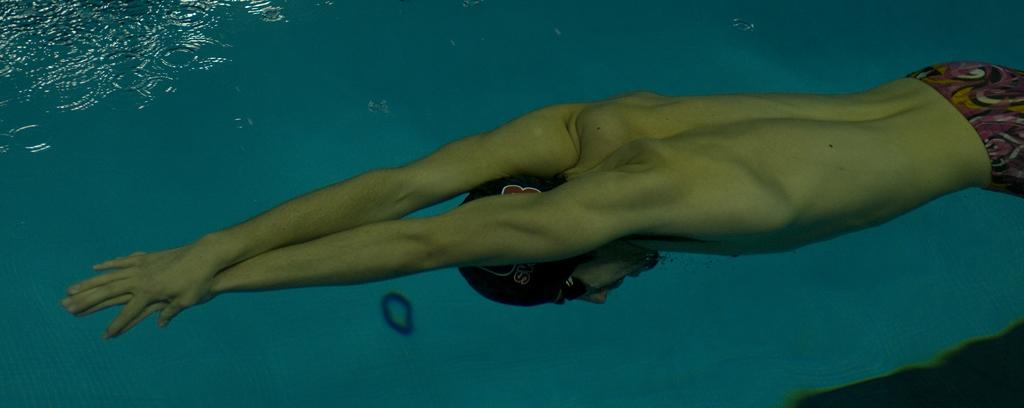What is the main subject of the image? There is a car in the image. What activity is being performed by a person in the image? There is a person swimming in the water in the image. What type of environment is depicted in the image? There is water visible in the image. What is the process of the car turning into a boat in the image? There is no indication in the image that the car is turning into a boat, and therefore no such process can be observed. 